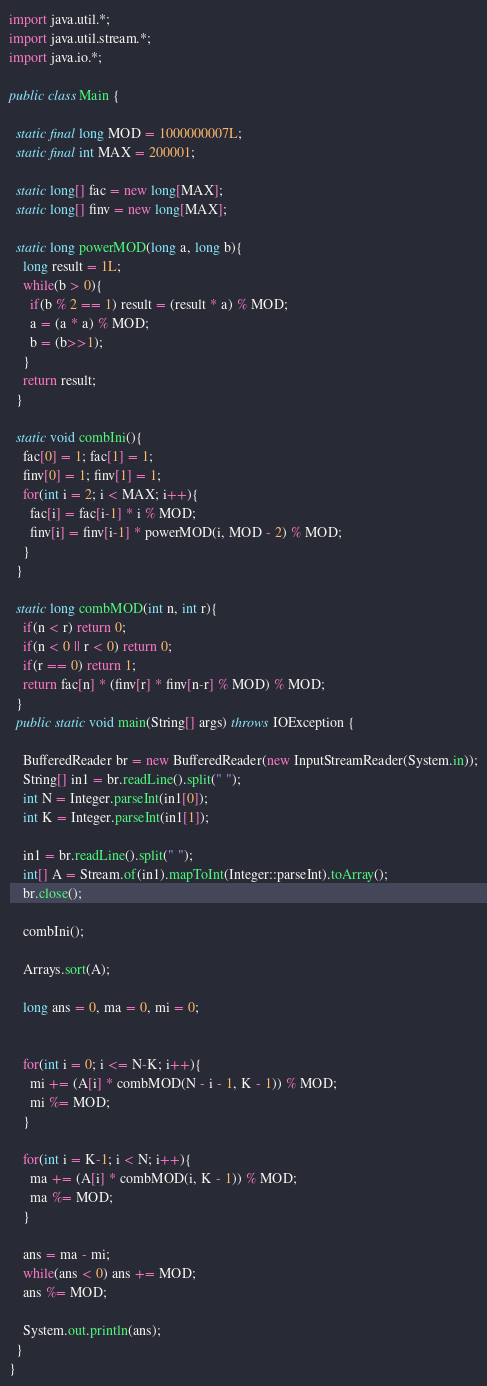Convert code to text. <code><loc_0><loc_0><loc_500><loc_500><_Java_>import java.util.*;
import java.util.stream.*;
import java.io.*;

public class Main {

  static final long MOD = 1000000007L;
  static final int MAX = 200001;

  static long[] fac = new long[MAX];
  static long[] finv = new long[MAX];

  static long powerMOD(long a, long b){
    long result = 1L;
    while(b > 0){
      if(b % 2 == 1) result = (result * a) % MOD;
      a = (a * a) % MOD;
      b = (b>>1);
    }
    return result;
  }

  static void combIni(){
    fac[0] = 1; fac[1] = 1;
    finv[0] = 1; finv[1] = 1;
    for(int i = 2; i < MAX; i++){
      fac[i] = fac[i-1] * i % MOD;
      finv[i] = finv[i-1] * powerMOD(i, MOD - 2) % MOD;
    }
  }

  static long combMOD(int n, int r){
    if(n < r) return 0;
    if(n < 0 || r < 0) return 0;
    if(r == 0) return 1;
    return fac[n] * (finv[r] * finv[n-r] % MOD) % MOD;
  }
  public static void main(String[] args) throws IOException {

    BufferedReader br = new BufferedReader(new InputStreamReader(System.in));
    String[] in1 = br.readLine().split(" ");
    int N = Integer.parseInt(in1[0]);
    int K = Integer.parseInt(in1[1]);
    
    in1 = br.readLine().split(" ");
    int[] A = Stream.of(in1).mapToInt(Integer::parseInt).toArray();
    br.close();

    combIni();

    Arrays.sort(A);

    long ans = 0, ma = 0, mi = 0;


    for(int i = 0; i <= N-K; i++){
      mi += (A[i] * combMOD(N - i - 1, K - 1)) % MOD;
      mi %= MOD;
    }

    for(int i = K-1; i < N; i++){
      ma += (A[i] * combMOD(i, K - 1)) % MOD;
      ma %= MOD;
    }

    ans = ma - mi;
    while(ans < 0) ans += MOD;
    ans %= MOD;

    System.out.println(ans);
  }
}</code> 